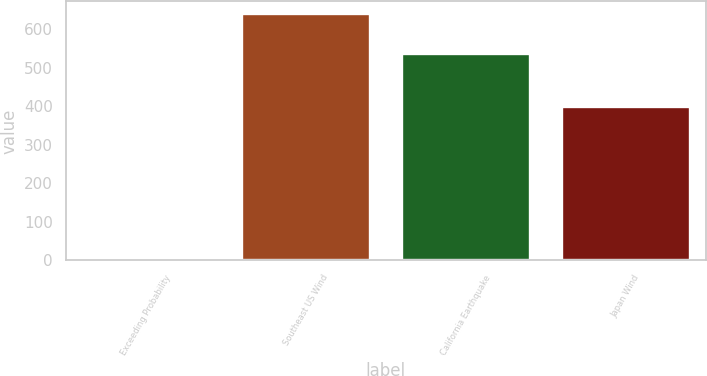Convert chart to OTSL. <chart><loc_0><loc_0><loc_500><loc_500><bar_chart><fcel>Exceeding Probability<fcel>Southeast US Wind<fcel>California Earthquake<fcel>Japan Wind<nl><fcel>1<fcel>640<fcel>536<fcel>399<nl></chart> 